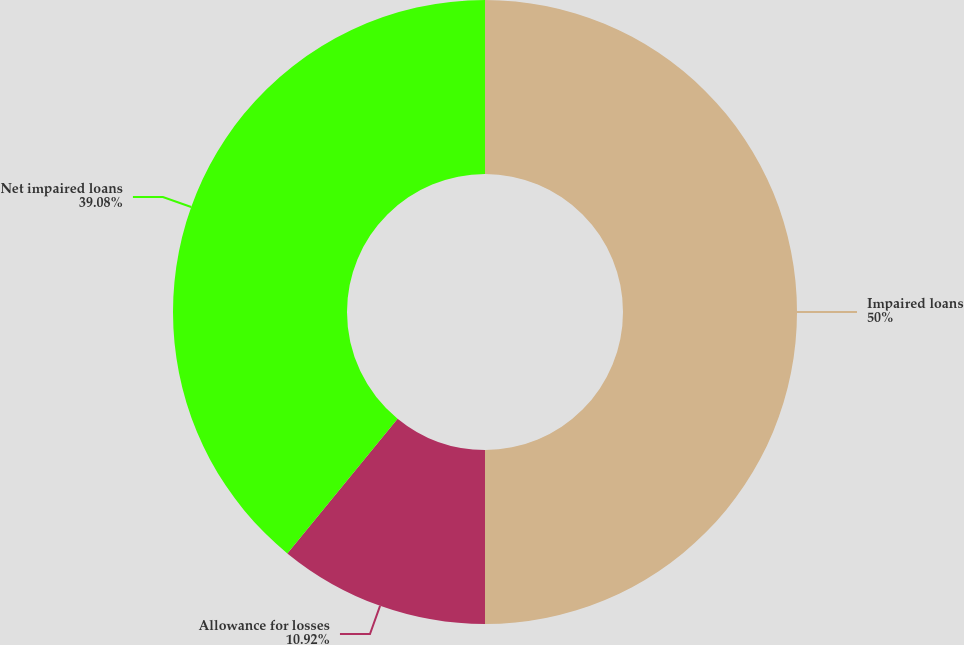<chart> <loc_0><loc_0><loc_500><loc_500><pie_chart><fcel>Impaired loans<fcel>Allowance for losses<fcel>Net impaired loans<nl><fcel>50.0%<fcel>10.92%<fcel>39.08%<nl></chart> 